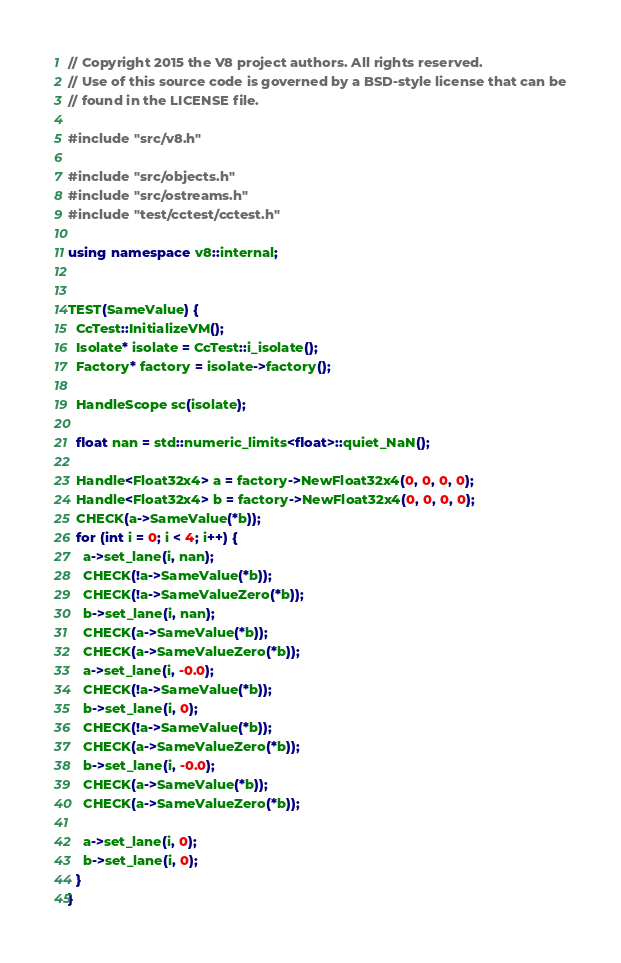Convert code to text. <code><loc_0><loc_0><loc_500><loc_500><_C++_>// Copyright 2015 the V8 project authors. All rights reserved.
// Use of this source code is governed by a BSD-style license that can be
// found in the LICENSE file.

#include "src/v8.h"

#include "src/objects.h"
#include "src/ostreams.h"
#include "test/cctest/cctest.h"

using namespace v8::internal;


TEST(SameValue) {
  CcTest::InitializeVM();
  Isolate* isolate = CcTest::i_isolate();
  Factory* factory = isolate->factory();

  HandleScope sc(isolate);

  float nan = std::numeric_limits<float>::quiet_NaN();

  Handle<Float32x4> a = factory->NewFloat32x4(0, 0, 0, 0);
  Handle<Float32x4> b = factory->NewFloat32x4(0, 0, 0, 0);
  CHECK(a->SameValue(*b));
  for (int i = 0; i < 4; i++) {
    a->set_lane(i, nan);
    CHECK(!a->SameValue(*b));
    CHECK(!a->SameValueZero(*b));
    b->set_lane(i, nan);
    CHECK(a->SameValue(*b));
    CHECK(a->SameValueZero(*b));
    a->set_lane(i, -0.0);
    CHECK(!a->SameValue(*b));
    b->set_lane(i, 0);
    CHECK(!a->SameValue(*b));
    CHECK(a->SameValueZero(*b));
    b->set_lane(i, -0.0);
    CHECK(a->SameValue(*b));
    CHECK(a->SameValueZero(*b));

    a->set_lane(i, 0);
    b->set_lane(i, 0);
  }
}
</code> 